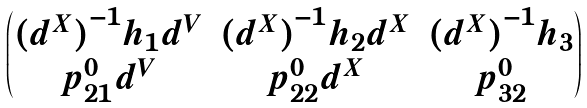Convert formula to latex. <formula><loc_0><loc_0><loc_500><loc_500>\begin{pmatrix} { ( d ^ { X } ) } ^ { - 1 } h _ { 1 } d ^ { V } & { ( d ^ { X } ) } ^ { - 1 } h _ { 2 } d ^ { X } & { ( d ^ { X } ) } ^ { - 1 } h _ { 3 } \\ p _ { 2 1 } ^ { 0 } d ^ { V } & p _ { 2 2 } ^ { 0 } d ^ { X } & p _ { 3 2 } ^ { 0 } \end{pmatrix}</formula> 